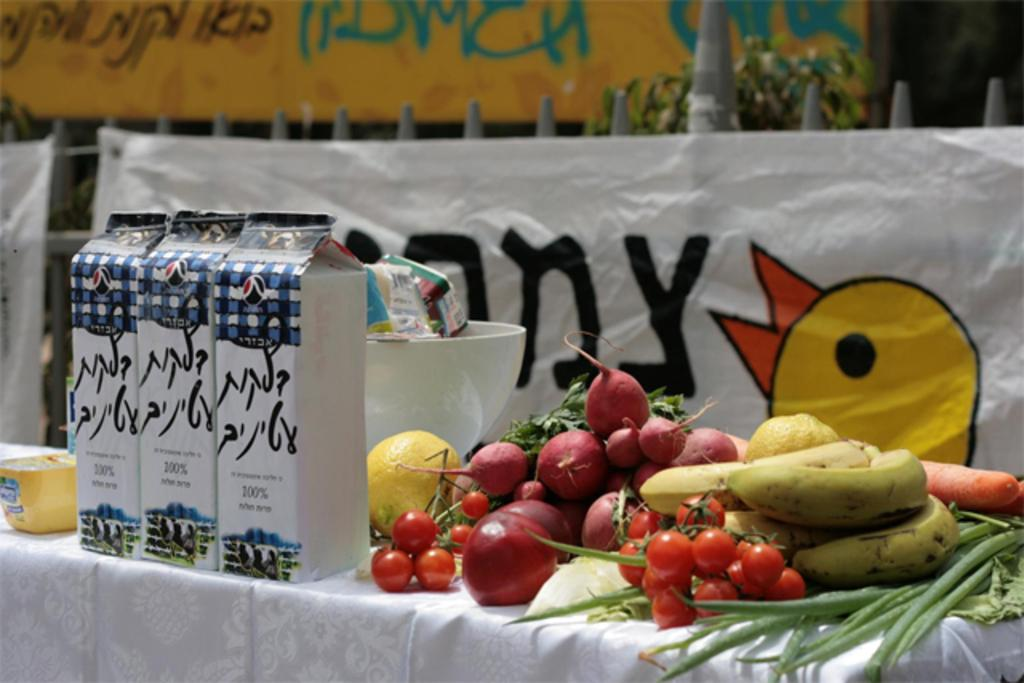What type of food items can be seen on the right side of the image? There are fruits on the right side of the image. What else is visible on the left side of the image? There are packets on the left side of the image. Can you describe the waves crashing on the shore in the image? There are no waves or shore visible in the image; it features fruits on the right side and packets on the left side. What type of wool is being used to create the scientific theory in the image? There is no wool or scientific theory present in the image. 